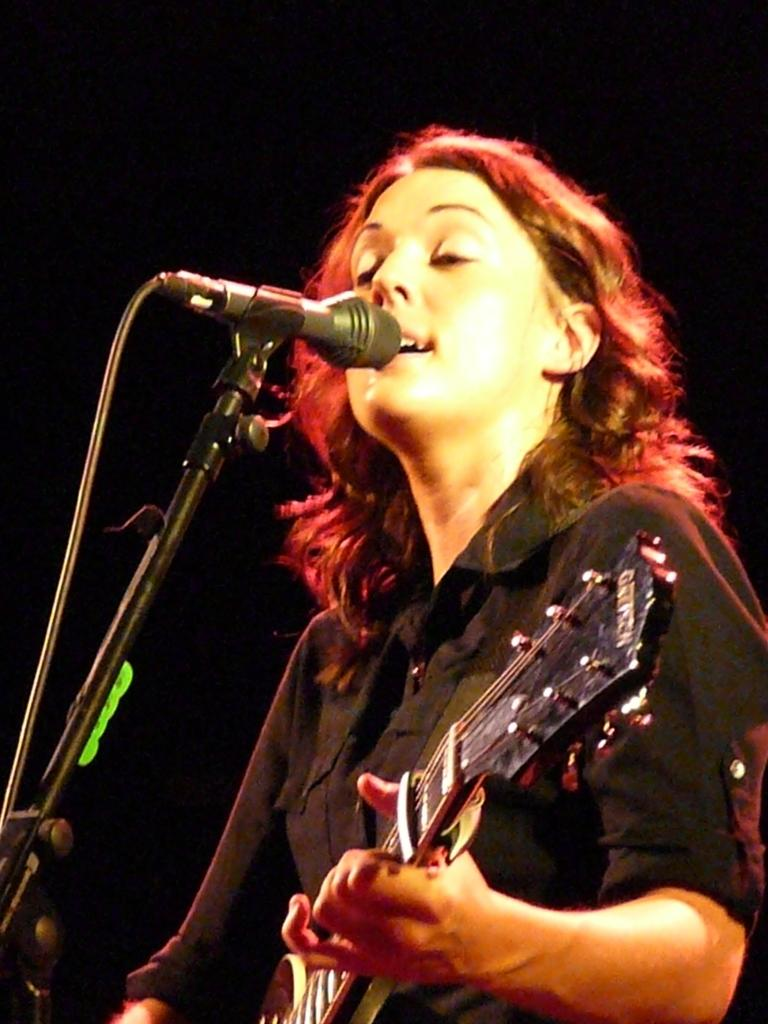What is the main subject of the image? The main subject of the image is a person standing in the center. What is the person holding in the image? The person is holding a guitar. What object is in front of the person? There is a microphone in front of the person. What type of operation is the person performing in the image? There is no indication of an operation in the image; the person is holding a guitar and standing near a microphone. Is the person driving a vehicle in the image? No, the person is not driving a vehicle in the image; they are standing with a guitar and a microphone. 